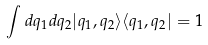<formula> <loc_0><loc_0><loc_500><loc_500>\int d q _ { 1 } d q _ { 2 } | q _ { 1 } , q _ { 2 } \rangle \langle q _ { 1 } , q _ { 2 } | = 1</formula> 